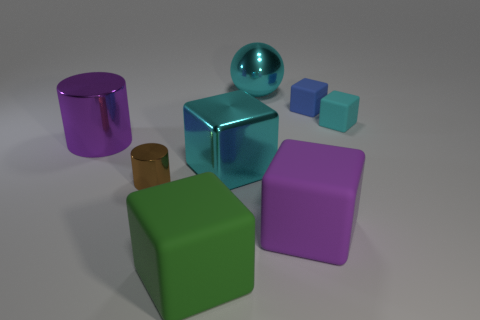Is the shape of the blue thing the same as the big cyan thing that is in front of the purple shiny cylinder?
Make the answer very short. Yes. Do the purple shiny thing and the cyan block that is on the left side of the tiny blue object have the same size?
Make the answer very short. Yes. What color is the big matte thing that is in front of the big rubber cube that is on the right side of the big cyan shiny ball?
Provide a succinct answer. Green. Do the purple cube and the blue rubber block have the same size?
Provide a succinct answer. No. There is a thing that is behind the cyan rubber cube and to the left of the purple matte cube; what is its color?
Give a very brief answer. Cyan. The purple shiny cylinder has what size?
Your response must be concise. Large. There is a rubber thing on the left side of the big ball; is it the same color as the metallic ball?
Your answer should be compact. No. Are there more brown metal cylinders in front of the small cyan object than cyan metal blocks that are in front of the purple matte cube?
Give a very brief answer. Yes. Is the number of large cyan shiny spheres greater than the number of metallic things?
Make the answer very short. No. What is the size of the metal thing that is both on the right side of the tiny brown metallic cylinder and in front of the tiny cyan object?
Provide a short and direct response. Large. 